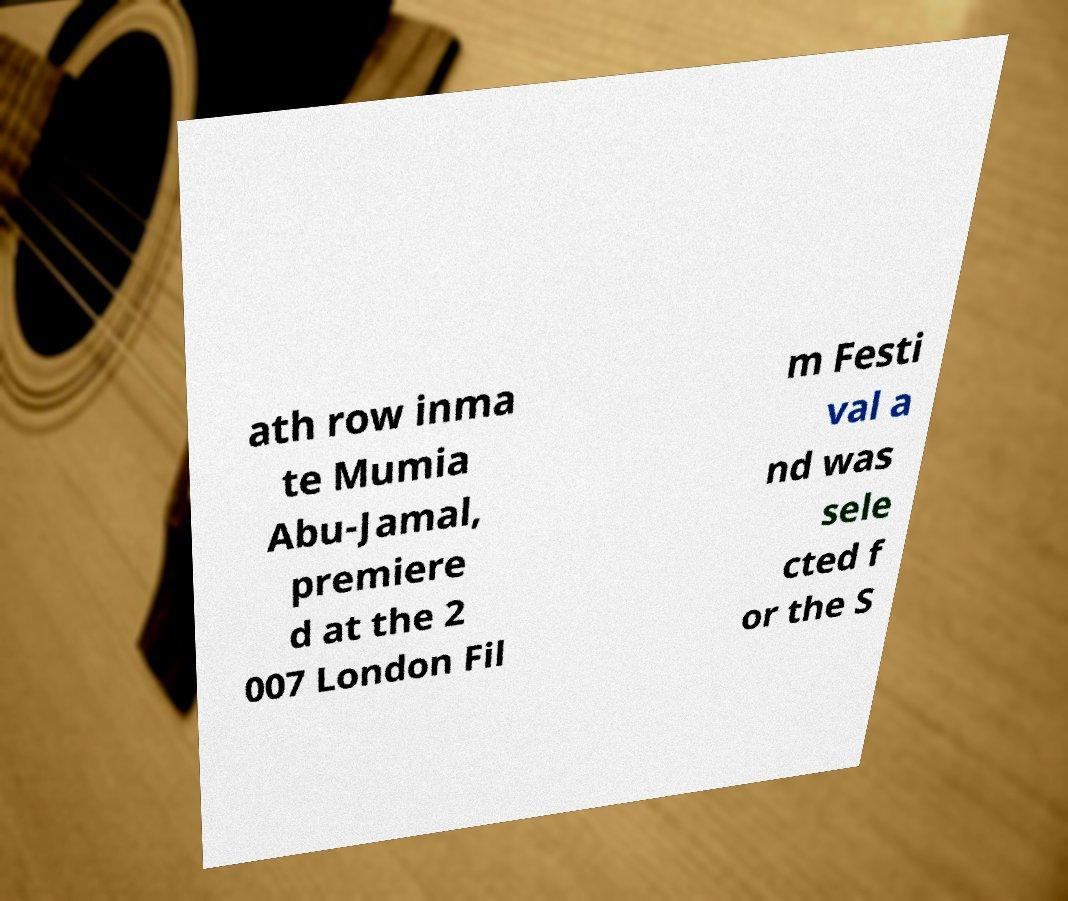Please read and relay the text visible in this image. What does it say? ath row inma te Mumia Abu-Jamal, premiere d at the 2 007 London Fil m Festi val a nd was sele cted f or the S 